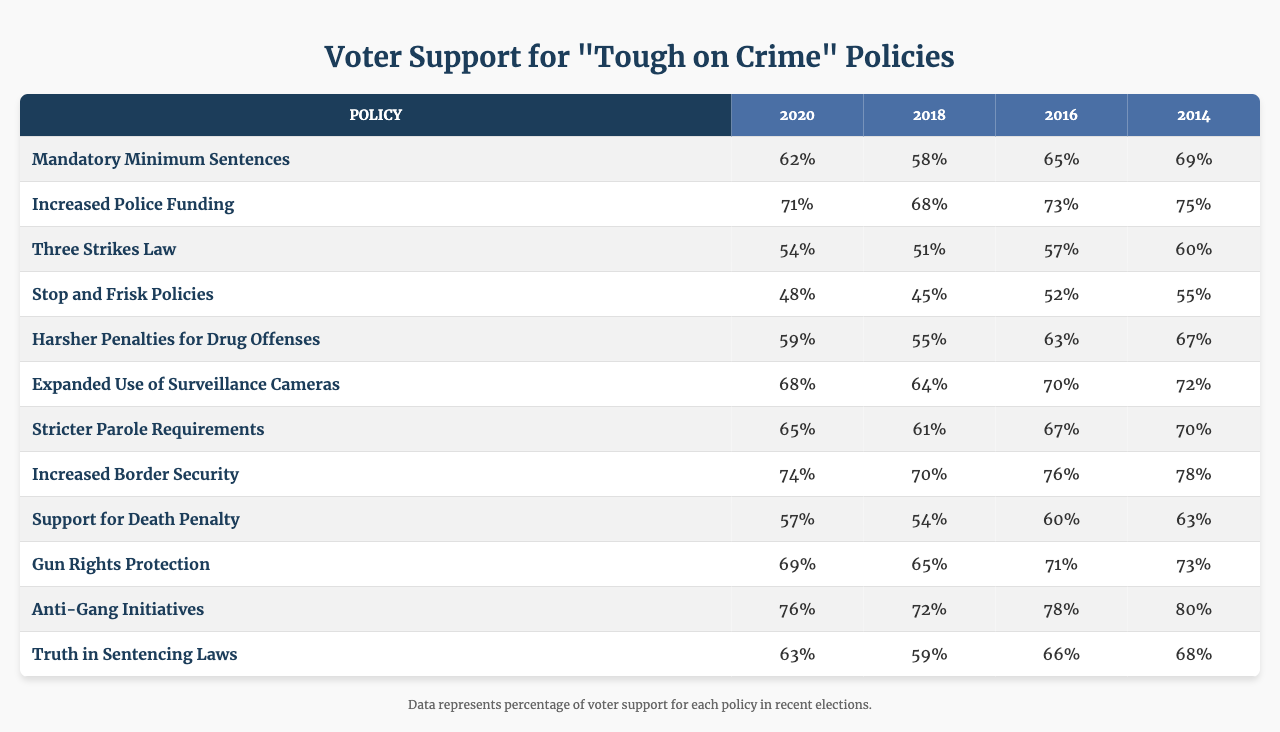What was the voter support percentage for increased police funding in 2020? In the table, under the column for the year 2020 and the row for increased police funding, the value is 71%.
Answer: 71% Which policy had the highest support among voters in 2018? Looking through the table for the year 2018, anti-gang initiatives had a support percentage of 72%, which is the highest compared to the other policies listed.
Answer: 72% What is the difference in voter support for harsher penalties for drug offenses between 2016 and 2014? For harsher penalties for drug offenses, the support was 63% in 2016 and 67% in 2014. The difference is 67 - 63 = 4%.
Answer: 4% Did voter support for truth in sentencing laws increase or decrease from 2014 to 2020? In 2014, the support was 68%, and in 2020, it was 63%. Since 63% is less than 68%, it indicates a decrease.
Answer: Decrease Calculate the average voter support for mandatory minimum sentences across all years. The values for mandatory minimum sentences are 62, 58, 65, and 69. Adding these values gives 62 + 58 + 65 + 69 = 254. There are 4 data points, so the average is 254 / 4 = 63.5%.
Answer: 63.5% What was the percentage of voter support for stop and frisk policies in 2016? According to the table, the value for stop and frisk policies in 2016 is 52%.
Answer: 52% Which policy saw the largest increase in voter support from 2014 to 2020? By comparing the percentages, increased border security went from 78% in 2014 to 74% in 2020 (a decrease), while anti-gang initiatives went from 80% in 2014 to 76% in 2020 (also a decrease). However, strict parole requirements improved from 70% in 2014 to 65% in 2020 (a decline), meaning none of these policies actually increased.
Answer: No increase found What was the voter support percentage for the gun rights protection policy in the election year with the least support? The table shows the percentages: 69% (2020), 65% (2018), 71% (2016), and 73% (2014). The least support occurred in 2018 with 65%.
Answer: 65% Is the support for the death penalty consistently above 55% in all election years? The support percentages for the death penalty are: 57% (2020), 54% (2018), 60% (2016), and 63% (2014). The support dropped below 55% in 2018, so it is not consistent across all years.
Answer: No Which two policies had the closest support percentages in 2020? Looking at the table for 2020, increased police funding (71%) and mandatory minimum sentences (62%) show the closest together. The difference between them is 9%, although harsher penalties for drug offenses (59%) is not too far behind. The closest pair of values without sorting would be between any two of those.
Answer: Increased police funding and mandatory minimum sentences 